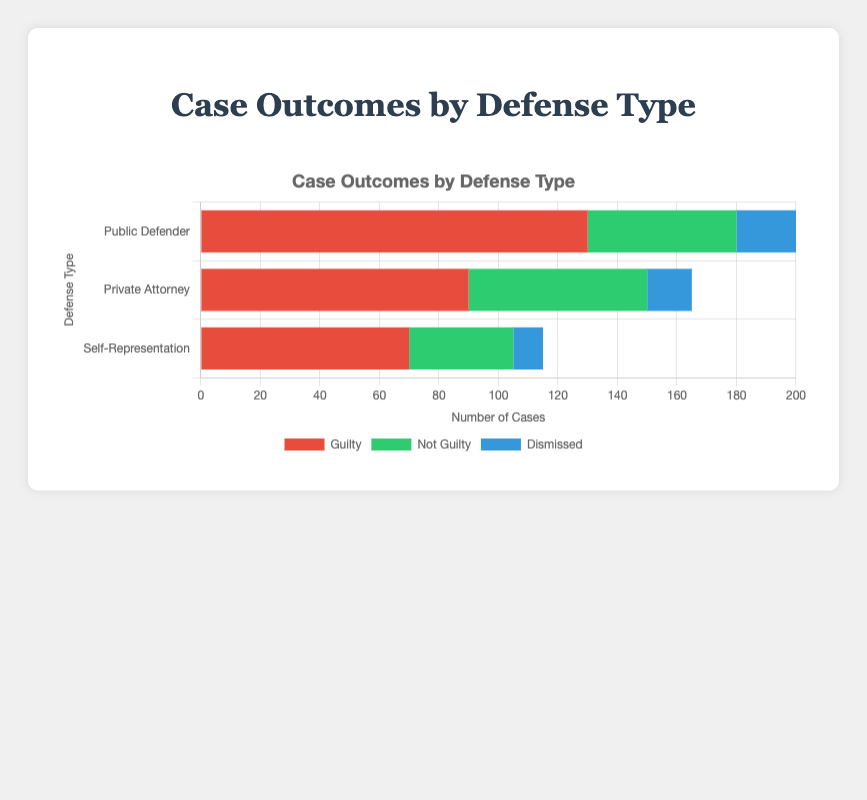Which defense type has the highest number of guilty verdicts? To find the defense type with the highest number of guilty verdicts, look at the bars representing guilty verdicts in red and compare their lengths. The bar for Public Defender is the longest.
Answer: Public Defender How many total cases were dismissed across all defense types? Add the dismissed cases for each defense type: 20 (Public Defender) + 15 (Private Attorney) + 10 (Self-Representation). This gives a total of 20 + 15 + 10 = 45 cases.
Answer: 45 What is the ratio of guilty to not guilty verdicts for those using a private attorney? For a private attorney, there are 90 guilty and 60 not guilty verdicts. The ratio is calculated as 90/60, which simplifies to 3:2.
Answer: 3:2 Are there more not guilty verdicts for public defenders or private attorneys? Compare the lengths of the green bars that represent not guilty verdicts for both Public Defender and Private Attorney. The bar for private attorneys is longer.
Answer: Private Attorneys What percentage of cases defended by self-representation resulted in a guilty verdict? For self-representation, there are 70 guilty verdicts out of a total of 70 (Guilty) + 35 (Not Guilty) + 10 (Dismissed) = 115 cases. The percentage is (70/115) * 100 ≈ 60.87%.
Answer: 60.87% Among the three defense types, which has the smallest proportion of dismissed cases? To determine the smallest proportion, calculate the proportion of dismissed cases for each defense type: 
- Public Defender: 20/(130 + 50 + 20) = 20/200 = 0.10
- Private Attorney: 15/(90 + 60 + 15) = 15/165 ≈ 0.09
- Self-Representation: 10/(70 + 35 + 10) = 10/115 ≈ 0.087
The smallest proportion is for Self-Representation.
Answer: Self-Representation Which defense type sees a greater difference between the number of guilty and not guilty verdicts? Calculate the difference between Guilty and Not Guilty Verdicts for each defense type:
- Public Defender: 130 - 50 = 80
- Private Attorney: 90 - 60 = 30
- Self-Representation: 70 - 35 = 35
The Public Defender shows the greatest difference of 80.
Answer: Public Defender What is the combined total of guilty and not guilty verdicts for self-representation? Add the guilty and not guilty verdict counts for self-representation: 70 (Guilty) + 35 (Not Guilty) = 105.
Answer: 105 